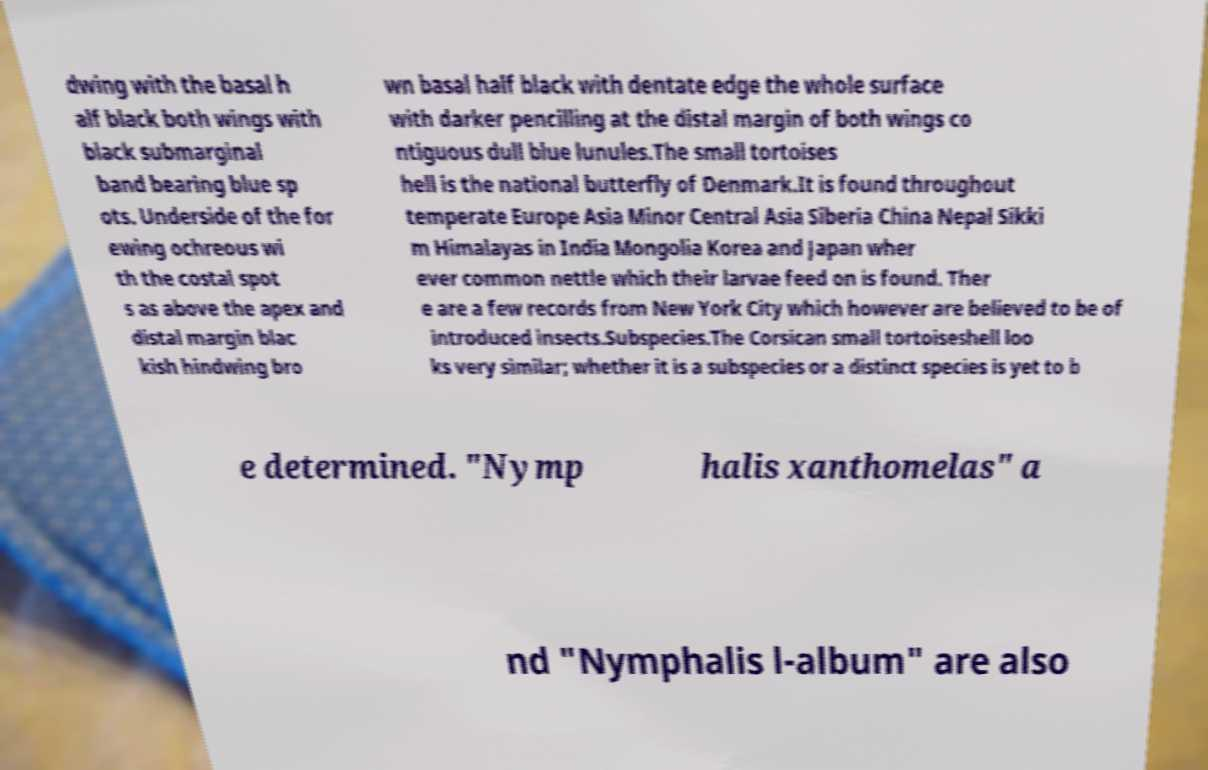Could you extract and type out the text from this image? dwing with the basal h alf black both wings with black submarginal band bearing blue sp ots. Underside of the for ewing ochreous wi th the costal spot s as above the apex and distal margin blac kish hindwing bro wn basal half black with dentate edge the whole surface with darker pencilling at the distal margin of both wings co ntiguous dull blue lunules.The small tortoises hell is the national butterfly of Denmark.It is found throughout temperate Europe Asia Minor Central Asia Siberia China Nepal Sikki m Himalayas in India Mongolia Korea and Japan wher ever common nettle which their larvae feed on is found. Ther e are a few records from New York City which however are believed to be of introduced insects.Subspecies.The Corsican small tortoiseshell loo ks very similar; whether it is a subspecies or a distinct species is yet to b e determined. "Nymp halis xanthomelas" a nd "Nymphalis l-album" are also 